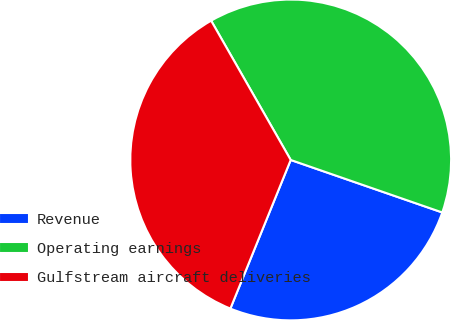<chart> <loc_0><loc_0><loc_500><loc_500><pie_chart><fcel>Revenue<fcel>Operating earnings<fcel>Gulfstream aircraft deliveries<nl><fcel>25.83%<fcel>38.57%<fcel>35.6%<nl></chart> 